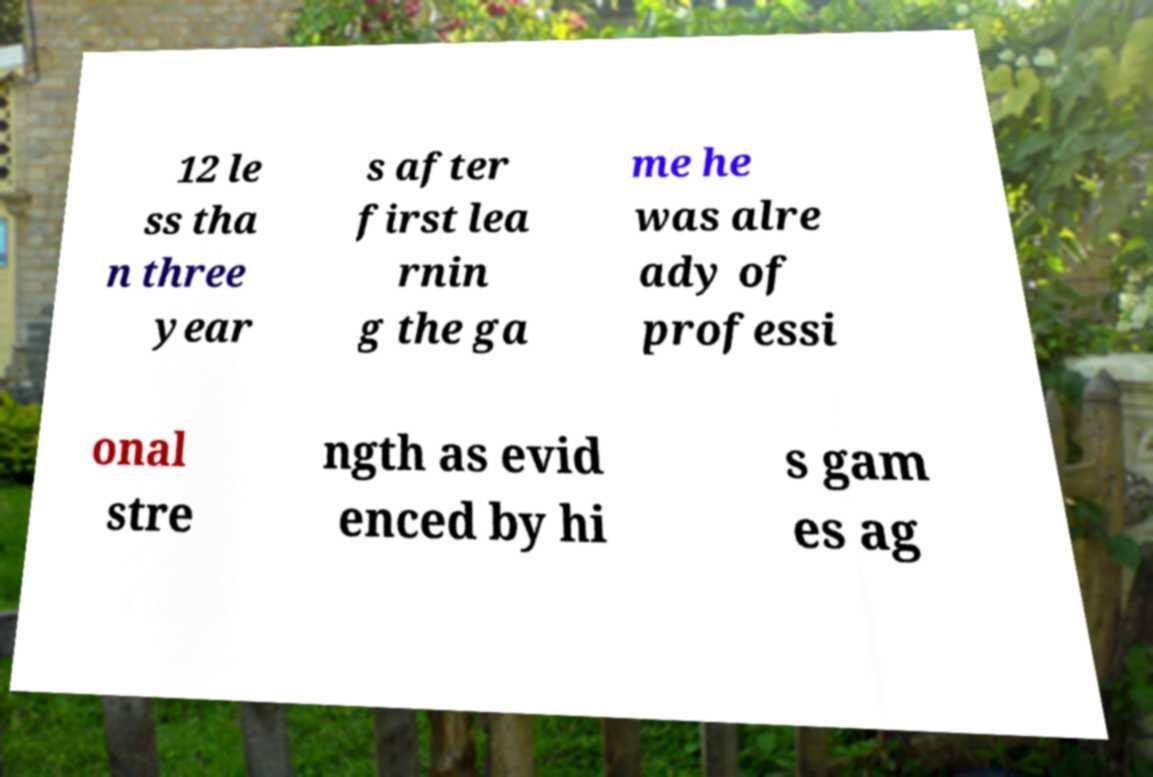Can you accurately transcribe the text from the provided image for me? 12 le ss tha n three year s after first lea rnin g the ga me he was alre ady of professi onal stre ngth as evid enced by hi s gam es ag 